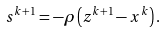Convert formula to latex. <formula><loc_0><loc_0><loc_500><loc_500>s ^ { k + 1 } = - \rho \left ( z ^ { k + 1 } - x ^ { k } \right ) .</formula> 